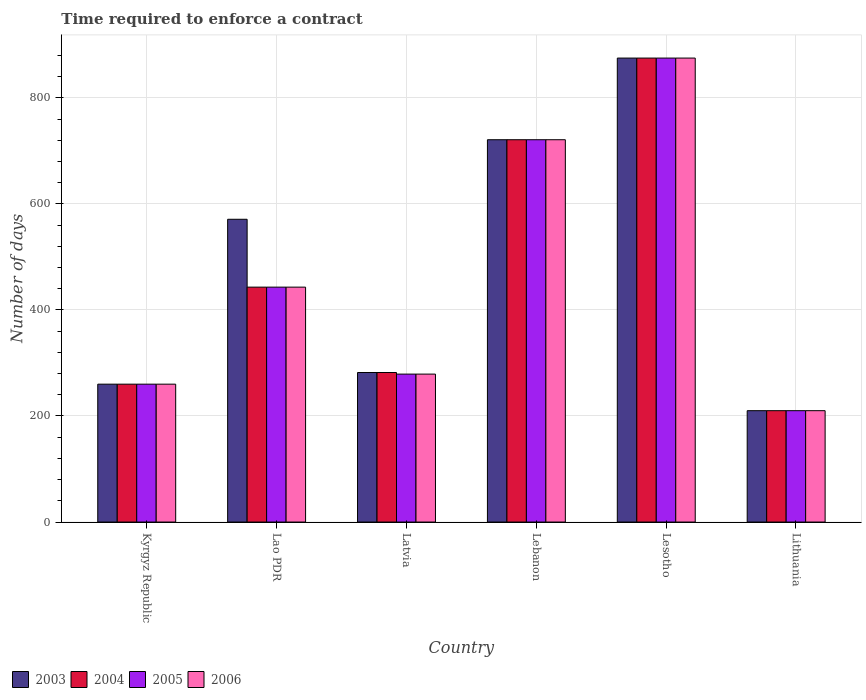How many groups of bars are there?
Offer a very short reply. 6. Are the number of bars per tick equal to the number of legend labels?
Your answer should be very brief. Yes. Are the number of bars on each tick of the X-axis equal?
Offer a terse response. Yes. How many bars are there on the 4th tick from the right?
Your answer should be compact. 4. What is the label of the 2nd group of bars from the left?
Offer a very short reply. Lao PDR. In how many cases, is the number of bars for a given country not equal to the number of legend labels?
Your answer should be very brief. 0. What is the number of days required to enforce a contract in 2006 in Lithuania?
Your response must be concise. 210. Across all countries, what is the maximum number of days required to enforce a contract in 2003?
Your answer should be very brief. 875. Across all countries, what is the minimum number of days required to enforce a contract in 2005?
Provide a succinct answer. 210. In which country was the number of days required to enforce a contract in 2005 maximum?
Your response must be concise. Lesotho. In which country was the number of days required to enforce a contract in 2005 minimum?
Provide a short and direct response. Lithuania. What is the total number of days required to enforce a contract in 2003 in the graph?
Provide a succinct answer. 2919. What is the difference between the number of days required to enforce a contract in 2006 in Lao PDR and that in Lebanon?
Provide a short and direct response. -278. What is the difference between the number of days required to enforce a contract in 2004 in Lao PDR and the number of days required to enforce a contract in 2006 in Kyrgyz Republic?
Provide a short and direct response. 183. What is the average number of days required to enforce a contract in 2006 per country?
Give a very brief answer. 464.67. What is the ratio of the number of days required to enforce a contract in 2005 in Lao PDR to that in Lebanon?
Your answer should be very brief. 0.61. Is the number of days required to enforce a contract in 2004 in Lebanon less than that in Lithuania?
Give a very brief answer. No. What is the difference between the highest and the second highest number of days required to enforce a contract in 2004?
Give a very brief answer. -154. What is the difference between the highest and the lowest number of days required to enforce a contract in 2003?
Provide a short and direct response. 665. Is it the case that in every country, the sum of the number of days required to enforce a contract in 2003 and number of days required to enforce a contract in 2006 is greater than the sum of number of days required to enforce a contract in 2004 and number of days required to enforce a contract in 2005?
Offer a terse response. No. What does the 1st bar from the right in Lebanon represents?
Your answer should be very brief. 2006. How many bars are there?
Your answer should be very brief. 24. Are all the bars in the graph horizontal?
Offer a very short reply. No. Are the values on the major ticks of Y-axis written in scientific E-notation?
Provide a succinct answer. No. Does the graph contain any zero values?
Give a very brief answer. No. Does the graph contain grids?
Keep it short and to the point. Yes. How are the legend labels stacked?
Keep it short and to the point. Horizontal. What is the title of the graph?
Ensure brevity in your answer.  Time required to enforce a contract. Does "2012" appear as one of the legend labels in the graph?
Make the answer very short. No. What is the label or title of the X-axis?
Offer a very short reply. Country. What is the label or title of the Y-axis?
Ensure brevity in your answer.  Number of days. What is the Number of days of 2003 in Kyrgyz Republic?
Your response must be concise. 260. What is the Number of days in 2004 in Kyrgyz Republic?
Your answer should be compact. 260. What is the Number of days in 2005 in Kyrgyz Republic?
Offer a very short reply. 260. What is the Number of days in 2006 in Kyrgyz Republic?
Provide a succinct answer. 260. What is the Number of days in 2003 in Lao PDR?
Your answer should be very brief. 571. What is the Number of days in 2004 in Lao PDR?
Provide a short and direct response. 443. What is the Number of days of 2005 in Lao PDR?
Ensure brevity in your answer.  443. What is the Number of days of 2006 in Lao PDR?
Offer a very short reply. 443. What is the Number of days of 2003 in Latvia?
Give a very brief answer. 282. What is the Number of days of 2004 in Latvia?
Your answer should be compact. 282. What is the Number of days in 2005 in Latvia?
Offer a terse response. 279. What is the Number of days of 2006 in Latvia?
Provide a short and direct response. 279. What is the Number of days of 2003 in Lebanon?
Offer a very short reply. 721. What is the Number of days of 2004 in Lebanon?
Your response must be concise. 721. What is the Number of days of 2005 in Lebanon?
Ensure brevity in your answer.  721. What is the Number of days in 2006 in Lebanon?
Your response must be concise. 721. What is the Number of days in 2003 in Lesotho?
Give a very brief answer. 875. What is the Number of days in 2004 in Lesotho?
Your answer should be very brief. 875. What is the Number of days of 2005 in Lesotho?
Ensure brevity in your answer.  875. What is the Number of days in 2006 in Lesotho?
Your response must be concise. 875. What is the Number of days of 2003 in Lithuania?
Keep it short and to the point. 210. What is the Number of days of 2004 in Lithuania?
Your answer should be compact. 210. What is the Number of days in 2005 in Lithuania?
Your response must be concise. 210. What is the Number of days of 2006 in Lithuania?
Offer a terse response. 210. Across all countries, what is the maximum Number of days in 2003?
Your answer should be compact. 875. Across all countries, what is the maximum Number of days in 2004?
Make the answer very short. 875. Across all countries, what is the maximum Number of days in 2005?
Your answer should be compact. 875. Across all countries, what is the maximum Number of days of 2006?
Provide a short and direct response. 875. Across all countries, what is the minimum Number of days of 2003?
Keep it short and to the point. 210. Across all countries, what is the minimum Number of days in 2004?
Provide a short and direct response. 210. Across all countries, what is the minimum Number of days in 2005?
Keep it short and to the point. 210. Across all countries, what is the minimum Number of days in 2006?
Keep it short and to the point. 210. What is the total Number of days in 2003 in the graph?
Your answer should be compact. 2919. What is the total Number of days of 2004 in the graph?
Provide a short and direct response. 2791. What is the total Number of days of 2005 in the graph?
Your answer should be very brief. 2788. What is the total Number of days of 2006 in the graph?
Provide a short and direct response. 2788. What is the difference between the Number of days of 2003 in Kyrgyz Republic and that in Lao PDR?
Keep it short and to the point. -311. What is the difference between the Number of days in 2004 in Kyrgyz Republic and that in Lao PDR?
Offer a terse response. -183. What is the difference between the Number of days of 2005 in Kyrgyz Republic and that in Lao PDR?
Give a very brief answer. -183. What is the difference between the Number of days in 2006 in Kyrgyz Republic and that in Lao PDR?
Your answer should be compact. -183. What is the difference between the Number of days in 2004 in Kyrgyz Republic and that in Latvia?
Your response must be concise. -22. What is the difference between the Number of days of 2003 in Kyrgyz Republic and that in Lebanon?
Provide a succinct answer. -461. What is the difference between the Number of days in 2004 in Kyrgyz Republic and that in Lebanon?
Your answer should be compact. -461. What is the difference between the Number of days of 2005 in Kyrgyz Republic and that in Lebanon?
Provide a short and direct response. -461. What is the difference between the Number of days of 2006 in Kyrgyz Republic and that in Lebanon?
Ensure brevity in your answer.  -461. What is the difference between the Number of days of 2003 in Kyrgyz Republic and that in Lesotho?
Provide a short and direct response. -615. What is the difference between the Number of days of 2004 in Kyrgyz Republic and that in Lesotho?
Provide a short and direct response. -615. What is the difference between the Number of days in 2005 in Kyrgyz Republic and that in Lesotho?
Provide a short and direct response. -615. What is the difference between the Number of days in 2006 in Kyrgyz Republic and that in Lesotho?
Keep it short and to the point. -615. What is the difference between the Number of days of 2003 in Kyrgyz Republic and that in Lithuania?
Offer a very short reply. 50. What is the difference between the Number of days of 2004 in Kyrgyz Republic and that in Lithuania?
Give a very brief answer. 50. What is the difference between the Number of days of 2005 in Kyrgyz Republic and that in Lithuania?
Offer a terse response. 50. What is the difference between the Number of days in 2003 in Lao PDR and that in Latvia?
Your response must be concise. 289. What is the difference between the Number of days of 2004 in Lao PDR and that in Latvia?
Give a very brief answer. 161. What is the difference between the Number of days in 2005 in Lao PDR and that in Latvia?
Offer a very short reply. 164. What is the difference between the Number of days of 2006 in Lao PDR and that in Latvia?
Provide a short and direct response. 164. What is the difference between the Number of days in 2003 in Lao PDR and that in Lebanon?
Offer a very short reply. -150. What is the difference between the Number of days of 2004 in Lao PDR and that in Lebanon?
Make the answer very short. -278. What is the difference between the Number of days in 2005 in Lao PDR and that in Lebanon?
Your answer should be compact. -278. What is the difference between the Number of days of 2006 in Lao PDR and that in Lebanon?
Your answer should be very brief. -278. What is the difference between the Number of days of 2003 in Lao PDR and that in Lesotho?
Your answer should be very brief. -304. What is the difference between the Number of days of 2004 in Lao PDR and that in Lesotho?
Provide a short and direct response. -432. What is the difference between the Number of days of 2005 in Lao PDR and that in Lesotho?
Provide a succinct answer. -432. What is the difference between the Number of days of 2006 in Lao PDR and that in Lesotho?
Provide a succinct answer. -432. What is the difference between the Number of days in 2003 in Lao PDR and that in Lithuania?
Offer a terse response. 361. What is the difference between the Number of days in 2004 in Lao PDR and that in Lithuania?
Offer a very short reply. 233. What is the difference between the Number of days of 2005 in Lao PDR and that in Lithuania?
Provide a short and direct response. 233. What is the difference between the Number of days in 2006 in Lao PDR and that in Lithuania?
Keep it short and to the point. 233. What is the difference between the Number of days in 2003 in Latvia and that in Lebanon?
Offer a very short reply. -439. What is the difference between the Number of days of 2004 in Latvia and that in Lebanon?
Provide a succinct answer. -439. What is the difference between the Number of days of 2005 in Latvia and that in Lebanon?
Make the answer very short. -442. What is the difference between the Number of days of 2006 in Latvia and that in Lebanon?
Give a very brief answer. -442. What is the difference between the Number of days of 2003 in Latvia and that in Lesotho?
Give a very brief answer. -593. What is the difference between the Number of days of 2004 in Latvia and that in Lesotho?
Provide a succinct answer. -593. What is the difference between the Number of days in 2005 in Latvia and that in Lesotho?
Offer a very short reply. -596. What is the difference between the Number of days of 2006 in Latvia and that in Lesotho?
Offer a very short reply. -596. What is the difference between the Number of days of 2006 in Latvia and that in Lithuania?
Keep it short and to the point. 69. What is the difference between the Number of days in 2003 in Lebanon and that in Lesotho?
Keep it short and to the point. -154. What is the difference between the Number of days in 2004 in Lebanon and that in Lesotho?
Your response must be concise. -154. What is the difference between the Number of days of 2005 in Lebanon and that in Lesotho?
Offer a very short reply. -154. What is the difference between the Number of days in 2006 in Lebanon and that in Lesotho?
Offer a terse response. -154. What is the difference between the Number of days of 2003 in Lebanon and that in Lithuania?
Your response must be concise. 511. What is the difference between the Number of days of 2004 in Lebanon and that in Lithuania?
Give a very brief answer. 511. What is the difference between the Number of days in 2005 in Lebanon and that in Lithuania?
Provide a succinct answer. 511. What is the difference between the Number of days in 2006 in Lebanon and that in Lithuania?
Provide a succinct answer. 511. What is the difference between the Number of days of 2003 in Lesotho and that in Lithuania?
Make the answer very short. 665. What is the difference between the Number of days in 2004 in Lesotho and that in Lithuania?
Make the answer very short. 665. What is the difference between the Number of days in 2005 in Lesotho and that in Lithuania?
Offer a terse response. 665. What is the difference between the Number of days of 2006 in Lesotho and that in Lithuania?
Offer a terse response. 665. What is the difference between the Number of days of 2003 in Kyrgyz Republic and the Number of days of 2004 in Lao PDR?
Ensure brevity in your answer.  -183. What is the difference between the Number of days of 2003 in Kyrgyz Republic and the Number of days of 2005 in Lao PDR?
Your answer should be compact. -183. What is the difference between the Number of days of 2003 in Kyrgyz Republic and the Number of days of 2006 in Lao PDR?
Your answer should be compact. -183. What is the difference between the Number of days of 2004 in Kyrgyz Republic and the Number of days of 2005 in Lao PDR?
Ensure brevity in your answer.  -183. What is the difference between the Number of days in 2004 in Kyrgyz Republic and the Number of days in 2006 in Lao PDR?
Provide a succinct answer. -183. What is the difference between the Number of days of 2005 in Kyrgyz Republic and the Number of days of 2006 in Lao PDR?
Your answer should be compact. -183. What is the difference between the Number of days in 2003 in Kyrgyz Republic and the Number of days in 2004 in Latvia?
Keep it short and to the point. -22. What is the difference between the Number of days of 2003 in Kyrgyz Republic and the Number of days of 2006 in Latvia?
Offer a very short reply. -19. What is the difference between the Number of days in 2004 in Kyrgyz Republic and the Number of days in 2005 in Latvia?
Your answer should be very brief. -19. What is the difference between the Number of days in 2004 in Kyrgyz Republic and the Number of days in 2006 in Latvia?
Make the answer very short. -19. What is the difference between the Number of days in 2003 in Kyrgyz Republic and the Number of days in 2004 in Lebanon?
Your response must be concise. -461. What is the difference between the Number of days in 2003 in Kyrgyz Republic and the Number of days in 2005 in Lebanon?
Provide a succinct answer. -461. What is the difference between the Number of days in 2003 in Kyrgyz Republic and the Number of days in 2006 in Lebanon?
Provide a succinct answer. -461. What is the difference between the Number of days of 2004 in Kyrgyz Republic and the Number of days of 2005 in Lebanon?
Offer a very short reply. -461. What is the difference between the Number of days in 2004 in Kyrgyz Republic and the Number of days in 2006 in Lebanon?
Ensure brevity in your answer.  -461. What is the difference between the Number of days of 2005 in Kyrgyz Republic and the Number of days of 2006 in Lebanon?
Ensure brevity in your answer.  -461. What is the difference between the Number of days in 2003 in Kyrgyz Republic and the Number of days in 2004 in Lesotho?
Your answer should be very brief. -615. What is the difference between the Number of days in 2003 in Kyrgyz Republic and the Number of days in 2005 in Lesotho?
Your answer should be compact. -615. What is the difference between the Number of days in 2003 in Kyrgyz Republic and the Number of days in 2006 in Lesotho?
Your response must be concise. -615. What is the difference between the Number of days in 2004 in Kyrgyz Republic and the Number of days in 2005 in Lesotho?
Provide a short and direct response. -615. What is the difference between the Number of days in 2004 in Kyrgyz Republic and the Number of days in 2006 in Lesotho?
Ensure brevity in your answer.  -615. What is the difference between the Number of days in 2005 in Kyrgyz Republic and the Number of days in 2006 in Lesotho?
Provide a short and direct response. -615. What is the difference between the Number of days of 2003 in Kyrgyz Republic and the Number of days of 2004 in Lithuania?
Provide a succinct answer. 50. What is the difference between the Number of days in 2003 in Kyrgyz Republic and the Number of days in 2005 in Lithuania?
Offer a very short reply. 50. What is the difference between the Number of days in 2003 in Kyrgyz Republic and the Number of days in 2006 in Lithuania?
Your answer should be compact. 50. What is the difference between the Number of days of 2004 in Kyrgyz Republic and the Number of days of 2005 in Lithuania?
Give a very brief answer. 50. What is the difference between the Number of days of 2003 in Lao PDR and the Number of days of 2004 in Latvia?
Your answer should be very brief. 289. What is the difference between the Number of days in 2003 in Lao PDR and the Number of days in 2005 in Latvia?
Provide a succinct answer. 292. What is the difference between the Number of days in 2003 in Lao PDR and the Number of days in 2006 in Latvia?
Give a very brief answer. 292. What is the difference between the Number of days of 2004 in Lao PDR and the Number of days of 2005 in Latvia?
Make the answer very short. 164. What is the difference between the Number of days of 2004 in Lao PDR and the Number of days of 2006 in Latvia?
Your answer should be very brief. 164. What is the difference between the Number of days in 2005 in Lao PDR and the Number of days in 2006 in Latvia?
Your answer should be very brief. 164. What is the difference between the Number of days of 2003 in Lao PDR and the Number of days of 2004 in Lebanon?
Offer a terse response. -150. What is the difference between the Number of days in 2003 in Lao PDR and the Number of days in 2005 in Lebanon?
Provide a short and direct response. -150. What is the difference between the Number of days of 2003 in Lao PDR and the Number of days of 2006 in Lebanon?
Offer a terse response. -150. What is the difference between the Number of days of 2004 in Lao PDR and the Number of days of 2005 in Lebanon?
Keep it short and to the point. -278. What is the difference between the Number of days in 2004 in Lao PDR and the Number of days in 2006 in Lebanon?
Your response must be concise. -278. What is the difference between the Number of days of 2005 in Lao PDR and the Number of days of 2006 in Lebanon?
Your answer should be compact. -278. What is the difference between the Number of days in 2003 in Lao PDR and the Number of days in 2004 in Lesotho?
Offer a terse response. -304. What is the difference between the Number of days of 2003 in Lao PDR and the Number of days of 2005 in Lesotho?
Provide a succinct answer. -304. What is the difference between the Number of days of 2003 in Lao PDR and the Number of days of 2006 in Lesotho?
Your answer should be very brief. -304. What is the difference between the Number of days in 2004 in Lao PDR and the Number of days in 2005 in Lesotho?
Your response must be concise. -432. What is the difference between the Number of days of 2004 in Lao PDR and the Number of days of 2006 in Lesotho?
Keep it short and to the point. -432. What is the difference between the Number of days in 2005 in Lao PDR and the Number of days in 2006 in Lesotho?
Offer a very short reply. -432. What is the difference between the Number of days of 2003 in Lao PDR and the Number of days of 2004 in Lithuania?
Your answer should be compact. 361. What is the difference between the Number of days in 2003 in Lao PDR and the Number of days in 2005 in Lithuania?
Make the answer very short. 361. What is the difference between the Number of days in 2003 in Lao PDR and the Number of days in 2006 in Lithuania?
Ensure brevity in your answer.  361. What is the difference between the Number of days of 2004 in Lao PDR and the Number of days of 2005 in Lithuania?
Ensure brevity in your answer.  233. What is the difference between the Number of days in 2004 in Lao PDR and the Number of days in 2006 in Lithuania?
Offer a very short reply. 233. What is the difference between the Number of days of 2005 in Lao PDR and the Number of days of 2006 in Lithuania?
Provide a succinct answer. 233. What is the difference between the Number of days in 2003 in Latvia and the Number of days in 2004 in Lebanon?
Provide a succinct answer. -439. What is the difference between the Number of days in 2003 in Latvia and the Number of days in 2005 in Lebanon?
Ensure brevity in your answer.  -439. What is the difference between the Number of days of 2003 in Latvia and the Number of days of 2006 in Lebanon?
Ensure brevity in your answer.  -439. What is the difference between the Number of days in 2004 in Latvia and the Number of days in 2005 in Lebanon?
Your response must be concise. -439. What is the difference between the Number of days of 2004 in Latvia and the Number of days of 2006 in Lebanon?
Provide a succinct answer. -439. What is the difference between the Number of days of 2005 in Latvia and the Number of days of 2006 in Lebanon?
Give a very brief answer. -442. What is the difference between the Number of days of 2003 in Latvia and the Number of days of 2004 in Lesotho?
Provide a short and direct response. -593. What is the difference between the Number of days in 2003 in Latvia and the Number of days in 2005 in Lesotho?
Ensure brevity in your answer.  -593. What is the difference between the Number of days in 2003 in Latvia and the Number of days in 2006 in Lesotho?
Offer a very short reply. -593. What is the difference between the Number of days in 2004 in Latvia and the Number of days in 2005 in Lesotho?
Make the answer very short. -593. What is the difference between the Number of days in 2004 in Latvia and the Number of days in 2006 in Lesotho?
Offer a terse response. -593. What is the difference between the Number of days in 2005 in Latvia and the Number of days in 2006 in Lesotho?
Your answer should be very brief. -596. What is the difference between the Number of days in 2003 in Lebanon and the Number of days in 2004 in Lesotho?
Keep it short and to the point. -154. What is the difference between the Number of days of 2003 in Lebanon and the Number of days of 2005 in Lesotho?
Make the answer very short. -154. What is the difference between the Number of days in 2003 in Lebanon and the Number of days in 2006 in Lesotho?
Make the answer very short. -154. What is the difference between the Number of days in 2004 in Lebanon and the Number of days in 2005 in Lesotho?
Provide a short and direct response. -154. What is the difference between the Number of days of 2004 in Lebanon and the Number of days of 2006 in Lesotho?
Your response must be concise. -154. What is the difference between the Number of days of 2005 in Lebanon and the Number of days of 2006 in Lesotho?
Provide a short and direct response. -154. What is the difference between the Number of days in 2003 in Lebanon and the Number of days in 2004 in Lithuania?
Ensure brevity in your answer.  511. What is the difference between the Number of days in 2003 in Lebanon and the Number of days in 2005 in Lithuania?
Make the answer very short. 511. What is the difference between the Number of days in 2003 in Lebanon and the Number of days in 2006 in Lithuania?
Offer a terse response. 511. What is the difference between the Number of days in 2004 in Lebanon and the Number of days in 2005 in Lithuania?
Your answer should be compact. 511. What is the difference between the Number of days in 2004 in Lebanon and the Number of days in 2006 in Lithuania?
Give a very brief answer. 511. What is the difference between the Number of days of 2005 in Lebanon and the Number of days of 2006 in Lithuania?
Your answer should be compact. 511. What is the difference between the Number of days in 2003 in Lesotho and the Number of days in 2004 in Lithuania?
Offer a very short reply. 665. What is the difference between the Number of days of 2003 in Lesotho and the Number of days of 2005 in Lithuania?
Provide a succinct answer. 665. What is the difference between the Number of days in 2003 in Lesotho and the Number of days in 2006 in Lithuania?
Ensure brevity in your answer.  665. What is the difference between the Number of days of 2004 in Lesotho and the Number of days of 2005 in Lithuania?
Your response must be concise. 665. What is the difference between the Number of days in 2004 in Lesotho and the Number of days in 2006 in Lithuania?
Your response must be concise. 665. What is the difference between the Number of days in 2005 in Lesotho and the Number of days in 2006 in Lithuania?
Give a very brief answer. 665. What is the average Number of days of 2003 per country?
Make the answer very short. 486.5. What is the average Number of days of 2004 per country?
Your answer should be very brief. 465.17. What is the average Number of days in 2005 per country?
Offer a very short reply. 464.67. What is the average Number of days of 2006 per country?
Make the answer very short. 464.67. What is the difference between the Number of days of 2003 and Number of days of 2004 in Kyrgyz Republic?
Your answer should be compact. 0. What is the difference between the Number of days in 2003 and Number of days in 2006 in Kyrgyz Republic?
Make the answer very short. 0. What is the difference between the Number of days of 2004 and Number of days of 2005 in Kyrgyz Republic?
Ensure brevity in your answer.  0. What is the difference between the Number of days of 2004 and Number of days of 2006 in Kyrgyz Republic?
Ensure brevity in your answer.  0. What is the difference between the Number of days in 2003 and Number of days in 2004 in Lao PDR?
Offer a terse response. 128. What is the difference between the Number of days of 2003 and Number of days of 2005 in Lao PDR?
Provide a succinct answer. 128. What is the difference between the Number of days in 2003 and Number of days in 2006 in Lao PDR?
Ensure brevity in your answer.  128. What is the difference between the Number of days in 2004 and Number of days in 2005 in Lao PDR?
Your response must be concise. 0. What is the difference between the Number of days of 2003 and Number of days of 2004 in Latvia?
Your response must be concise. 0. What is the difference between the Number of days in 2005 and Number of days in 2006 in Latvia?
Your answer should be very brief. 0. What is the difference between the Number of days of 2004 and Number of days of 2005 in Lebanon?
Offer a very short reply. 0. What is the difference between the Number of days of 2004 and Number of days of 2006 in Lebanon?
Make the answer very short. 0. What is the difference between the Number of days of 2005 and Number of days of 2006 in Lebanon?
Offer a very short reply. 0. What is the difference between the Number of days in 2003 and Number of days in 2005 in Lesotho?
Provide a short and direct response. 0. What is the difference between the Number of days of 2003 and Number of days of 2006 in Lesotho?
Offer a very short reply. 0. What is the difference between the Number of days of 2005 and Number of days of 2006 in Lesotho?
Ensure brevity in your answer.  0. What is the difference between the Number of days of 2003 and Number of days of 2004 in Lithuania?
Your answer should be very brief. 0. What is the difference between the Number of days of 2003 and Number of days of 2005 in Lithuania?
Provide a short and direct response. 0. What is the difference between the Number of days of 2003 and Number of days of 2006 in Lithuania?
Provide a short and direct response. 0. What is the difference between the Number of days in 2004 and Number of days in 2006 in Lithuania?
Your response must be concise. 0. What is the difference between the Number of days in 2005 and Number of days in 2006 in Lithuania?
Give a very brief answer. 0. What is the ratio of the Number of days of 2003 in Kyrgyz Republic to that in Lao PDR?
Keep it short and to the point. 0.46. What is the ratio of the Number of days of 2004 in Kyrgyz Republic to that in Lao PDR?
Provide a short and direct response. 0.59. What is the ratio of the Number of days in 2005 in Kyrgyz Republic to that in Lao PDR?
Your answer should be compact. 0.59. What is the ratio of the Number of days of 2006 in Kyrgyz Republic to that in Lao PDR?
Your answer should be compact. 0.59. What is the ratio of the Number of days in 2003 in Kyrgyz Republic to that in Latvia?
Provide a succinct answer. 0.92. What is the ratio of the Number of days of 2004 in Kyrgyz Republic to that in Latvia?
Make the answer very short. 0.92. What is the ratio of the Number of days in 2005 in Kyrgyz Republic to that in Latvia?
Your response must be concise. 0.93. What is the ratio of the Number of days in 2006 in Kyrgyz Republic to that in Latvia?
Provide a succinct answer. 0.93. What is the ratio of the Number of days of 2003 in Kyrgyz Republic to that in Lebanon?
Offer a very short reply. 0.36. What is the ratio of the Number of days of 2004 in Kyrgyz Republic to that in Lebanon?
Your answer should be very brief. 0.36. What is the ratio of the Number of days of 2005 in Kyrgyz Republic to that in Lebanon?
Offer a very short reply. 0.36. What is the ratio of the Number of days of 2006 in Kyrgyz Republic to that in Lebanon?
Keep it short and to the point. 0.36. What is the ratio of the Number of days in 2003 in Kyrgyz Republic to that in Lesotho?
Make the answer very short. 0.3. What is the ratio of the Number of days in 2004 in Kyrgyz Republic to that in Lesotho?
Ensure brevity in your answer.  0.3. What is the ratio of the Number of days in 2005 in Kyrgyz Republic to that in Lesotho?
Make the answer very short. 0.3. What is the ratio of the Number of days in 2006 in Kyrgyz Republic to that in Lesotho?
Ensure brevity in your answer.  0.3. What is the ratio of the Number of days in 2003 in Kyrgyz Republic to that in Lithuania?
Make the answer very short. 1.24. What is the ratio of the Number of days in 2004 in Kyrgyz Republic to that in Lithuania?
Provide a succinct answer. 1.24. What is the ratio of the Number of days in 2005 in Kyrgyz Republic to that in Lithuania?
Your answer should be compact. 1.24. What is the ratio of the Number of days in 2006 in Kyrgyz Republic to that in Lithuania?
Give a very brief answer. 1.24. What is the ratio of the Number of days of 2003 in Lao PDR to that in Latvia?
Your answer should be very brief. 2.02. What is the ratio of the Number of days of 2004 in Lao PDR to that in Latvia?
Your answer should be compact. 1.57. What is the ratio of the Number of days of 2005 in Lao PDR to that in Latvia?
Provide a short and direct response. 1.59. What is the ratio of the Number of days in 2006 in Lao PDR to that in Latvia?
Provide a short and direct response. 1.59. What is the ratio of the Number of days in 2003 in Lao PDR to that in Lebanon?
Keep it short and to the point. 0.79. What is the ratio of the Number of days of 2004 in Lao PDR to that in Lebanon?
Give a very brief answer. 0.61. What is the ratio of the Number of days of 2005 in Lao PDR to that in Lebanon?
Keep it short and to the point. 0.61. What is the ratio of the Number of days in 2006 in Lao PDR to that in Lebanon?
Provide a succinct answer. 0.61. What is the ratio of the Number of days in 2003 in Lao PDR to that in Lesotho?
Your response must be concise. 0.65. What is the ratio of the Number of days of 2004 in Lao PDR to that in Lesotho?
Provide a succinct answer. 0.51. What is the ratio of the Number of days of 2005 in Lao PDR to that in Lesotho?
Keep it short and to the point. 0.51. What is the ratio of the Number of days in 2006 in Lao PDR to that in Lesotho?
Provide a short and direct response. 0.51. What is the ratio of the Number of days of 2003 in Lao PDR to that in Lithuania?
Keep it short and to the point. 2.72. What is the ratio of the Number of days in 2004 in Lao PDR to that in Lithuania?
Give a very brief answer. 2.11. What is the ratio of the Number of days of 2005 in Lao PDR to that in Lithuania?
Provide a succinct answer. 2.11. What is the ratio of the Number of days of 2006 in Lao PDR to that in Lithuania?
Offer a very short reply. 2.11. What is the ratio of the Number of days of 2003 in Latvia to that in Lebanon?
Offer a very short reply. 0.39. What is the ratio of the Number of days in 2004 in Latvia to that in Lebanon?
Provide a succinct answer. 0.39. What is the ratio of the Number of days in 2005 in Latvia to that in Lebanon?
Give a very brief answer. 0.39. What is the ratio of the Number of days of 2006 in Latvia to that in Lebanon?
Provide a short and direct response. 0.39. What is the ratio of the Number of days of 2003 in Latvia to that in Lesotho?
Make the answer very short. 0.32. What is the ratio of the Number of days in 2004 in Latvia to that in Lesotho?
Make the answer very short. 0.32. What is the ratio of the Number of days in 2005 in Latvia to that in Lesotho?
Your response must be concise. 0.32. What is the ratio of the Number of days in 2006 in Latvia to that in Lesotho?
Keep it short and to the point. 0.32. What is the ratio of the Number of days of 2003 in Latvia to that in Lithuania?
Your response must be concise. 1.34. What is the ratio of the Number of days of 2004 in Latvia to that in Lithuania?
Keep it short and to the point. 1.34. What is the ratio of the Number of days of 2005 in Latvia to that in Lithuania?
Provide a short and direct response. 1.33. What is the ratio of the Number of days in 2006 in Latvia to that in Lithuania?
Offer a very short reply. 1.33. What is the ratio of the Number of days in 2003 in Lebanon to that in Lesotho?
Provide a short and direct response. 0.82. What is the ratio of the Number of days in 2004 in Lebanon to that in Lesotho?
Your answer should be very brief. 0.82. What is the ratio of the Number of days of 2005 in Lebanon to that in Lesotho?
Make the answer very short. 0.82. What is the ratio of the Number of days of 2006 in Lebanon to that in Lesotho?
Ensure brevity in your answer.  0.82. What is the ratio of the Number of days in 2003 in Lebanon to that in Lithuania?
Your answer should be very brief. 3.43. What is the ratio of the Number of days in 2004 in Lebanon to that in Lithuania?
Give a very brief answer. 3.43. What is the ratio of the Number of days of 2005 in Lebanon to that in Lithuania?
Provide a succinct answer. 3.43. What is the ratio of the Number of days in 2006 in Lebanon to that in Lithuania?
Your response must be concise. 3.43. What is the ratio of the Number of days in 2003 in Lesotho to that in Lithuania?
Offer a very short reply. 4.17. What is the ratio of the Number of days of 2004 in Lesotho to that in Lithuania?
Provide a short and direct response. 4.17. What is the ratio of the Number of days in 2005 in Lesotho to that in Lithuania?
Make the answer very short. 4.17. What is the ratio of the Number of days in 2006 in Lesotho to that in Lithuania?
Offer a terse response. 4.17. What is the difference between the highest and the second highest Number of days in 2003?
Your answer should be compact. 154. What is the difference between the highest and the second highest Number of days in 2004?
Make the answer very short. 154. What is the difference between the highest and the second highest Number of days of 2005?
Keep it short and to the point. 154. What is the difference between the highest and the second highest Number of days of 2006?
Offer a terse response. 154. What is the difference between the highest and the lowest Number of days of 2003?
Make the answer very short. 665. What is the difference between the highest and the lowest Number of days in 2004?
Your answer should be very brief. 665. What is the difference between the highest and the lowest Number of days of 2005?
Provide a short and direct response. 665. What is the difference between the highest and the lowest Number of days of 2006?
Ensure brevity in your answer.  665. 